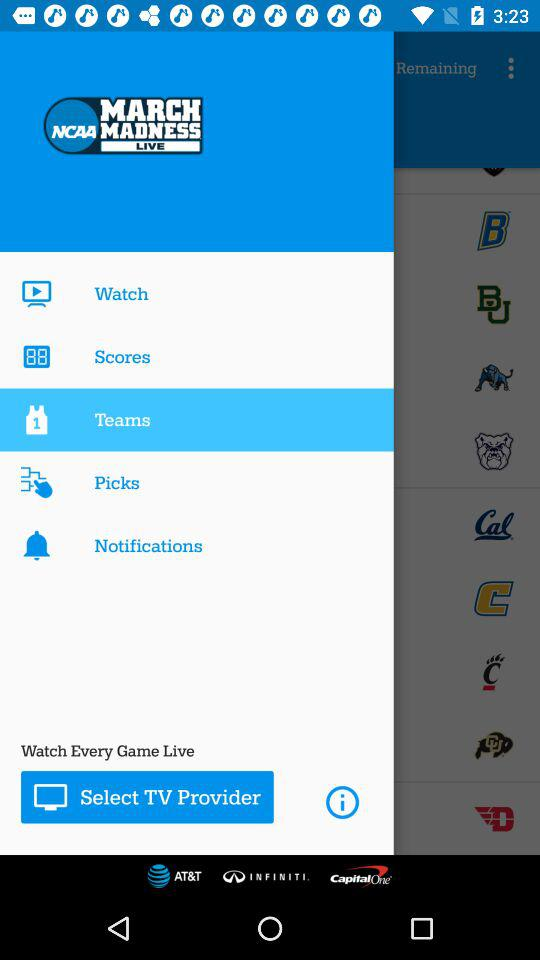What is the name of the application? The name of the application is "NCAA MARCH MADNESS LIVE". 